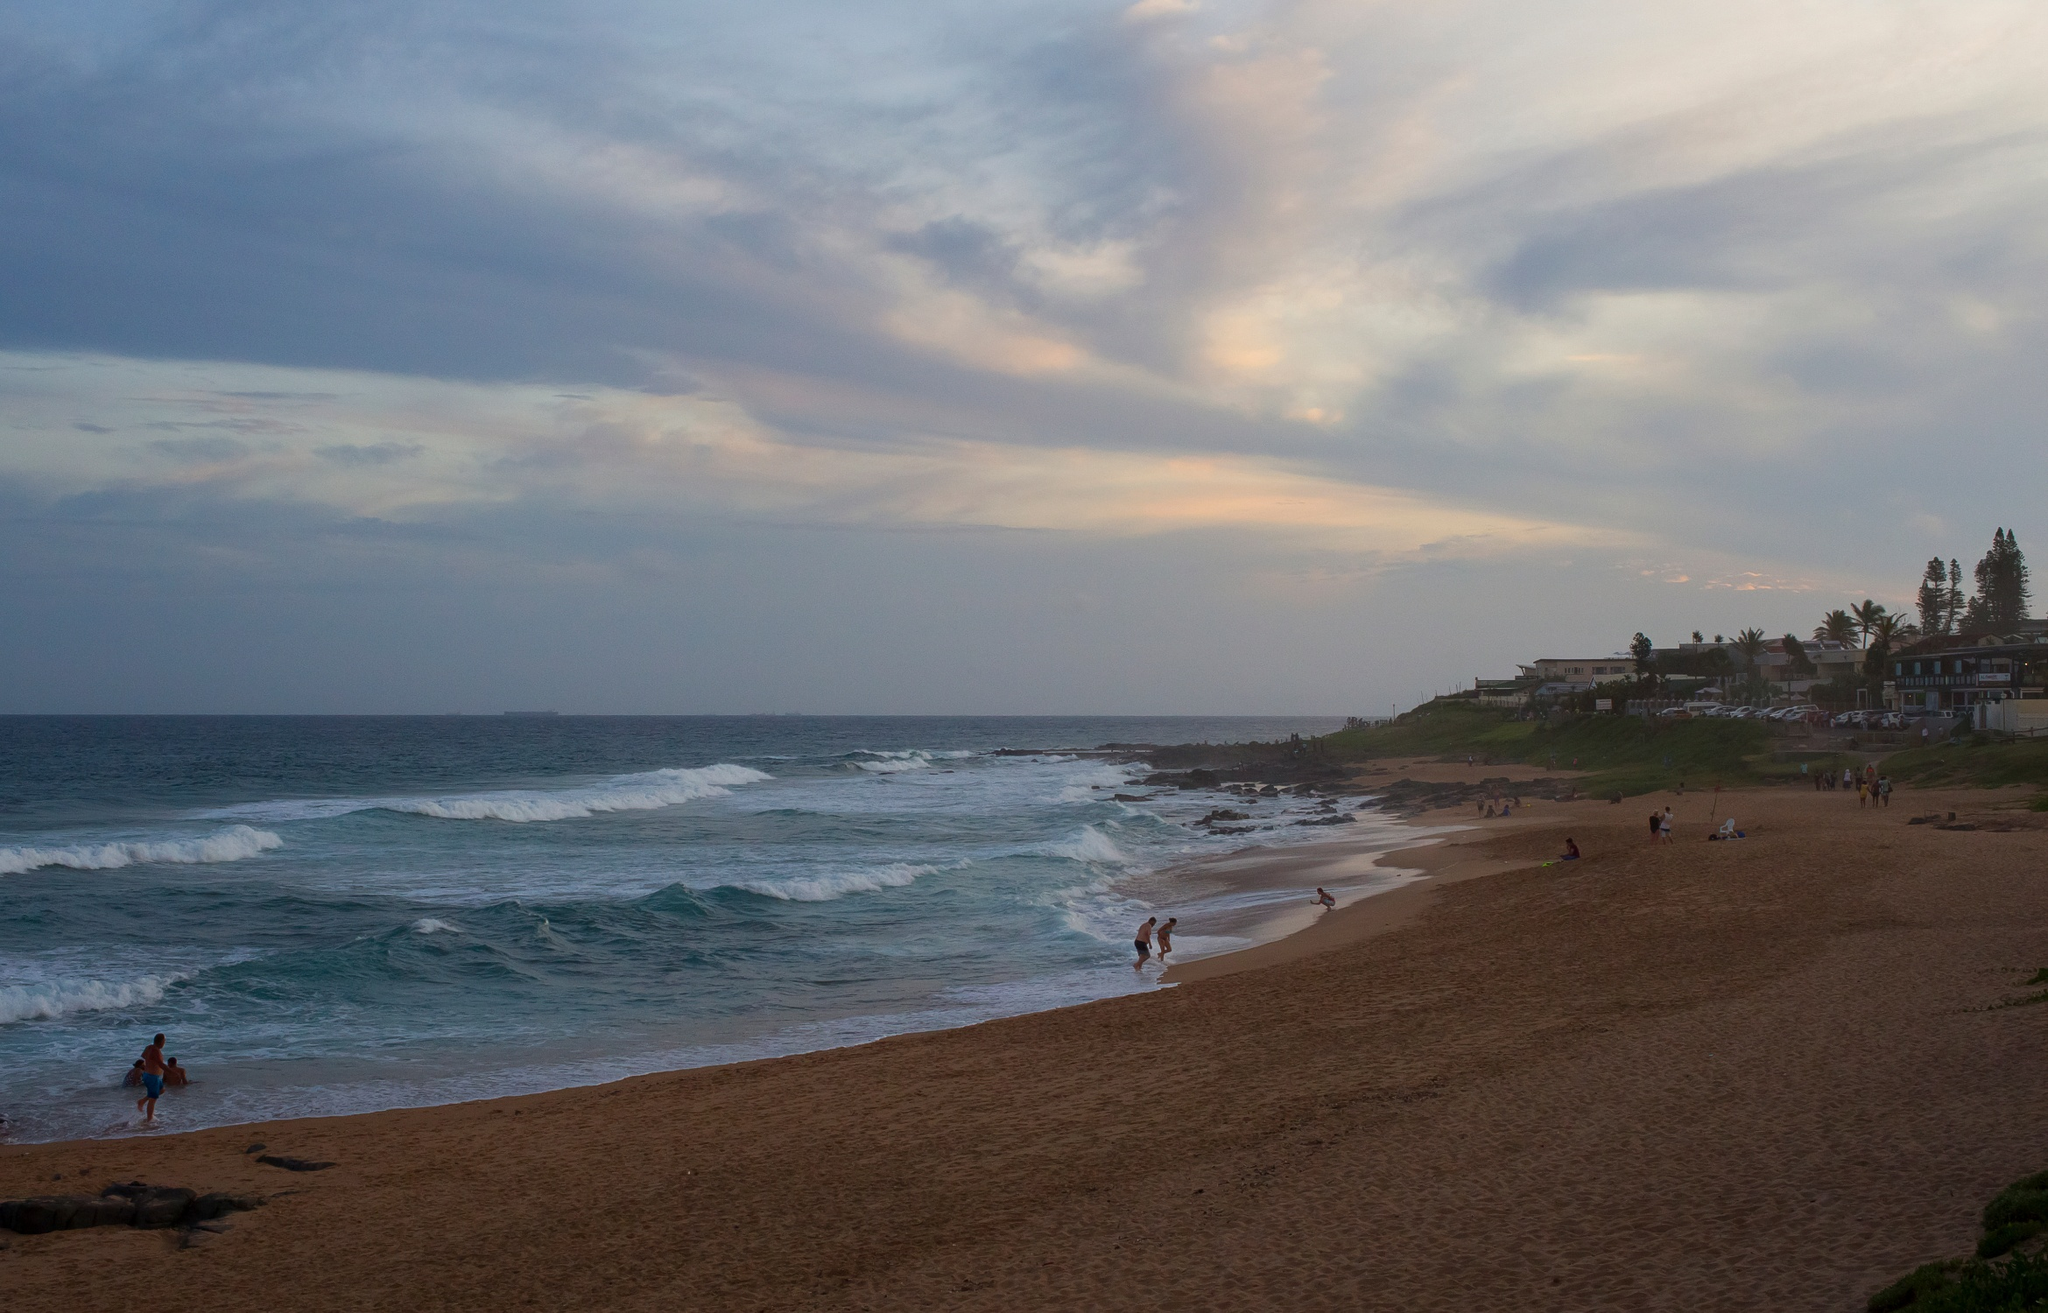What kind of flora and fauna might you find in this location? In a coastal area such as this, you would likely find a variety of flora and fauna adapted to the beach and cliff environment. The flora might include dune grasses, small shrubs, and coastal plants that thrive in sandy and salty conditions. Trees such as palms may be present near the houses on the cliff. As for fauna, you may find seabirds like seagulls frequenting the beach, and smaller shorebirds like sandpipers searching for food along the water's edge. Marine creatures such as crabs and mollusks could be hidden among the rocks and tide pools, while fish and other sea life inhabit the waters just off the shore. If you were to write a story set on this beach, what would it be about? A story set on this beach could revolve around a solitary artist who visits the beach every day at sunset to capture the breathtaking views on canvas. One evening, they encounter a mysterious figure who seems to appear out of nowhere, and as they strike up a conversation, they learn that this person is a time traveler from the past, brought to this serene spot by the power of the setting sun. The story would explore themes of connection, the passage of time, and the enduring beauty of nature as the unlikely pair share their stories and experiences, ultimately finding solace and inspiration in each other’s company. Can you imagine a day in the life of a local who lives in one of those houses on the cliff? A day in the life of a local living in one of the cliffside houses might start with waking up to the gentle sound of ocean waves. They might enjoy their morning coffee on a balcony overlooking the beach, watching the early risers take a stroll along the shore. After breakfast, they might head out for a morning walk or jog on the beach, soaking in the fresh sea breeze. Returning home, they might spend some time tending to a garden or working on a project. In the afternoon, they may visit a local market or cafe, meeting friends and neighbors. As the day progresses, they might enjoy reading a book or painting by the window with a view of the ocean. As sunset approaches, they head back to the balcony or the beach to watch the mesmerizing colors fill the sky. In the evening, they might have a quiet dinner with family, followed by a peaceful walk on the beach under the starlit sky before heading to bed, lulled to sleep by the sound of the waves. 